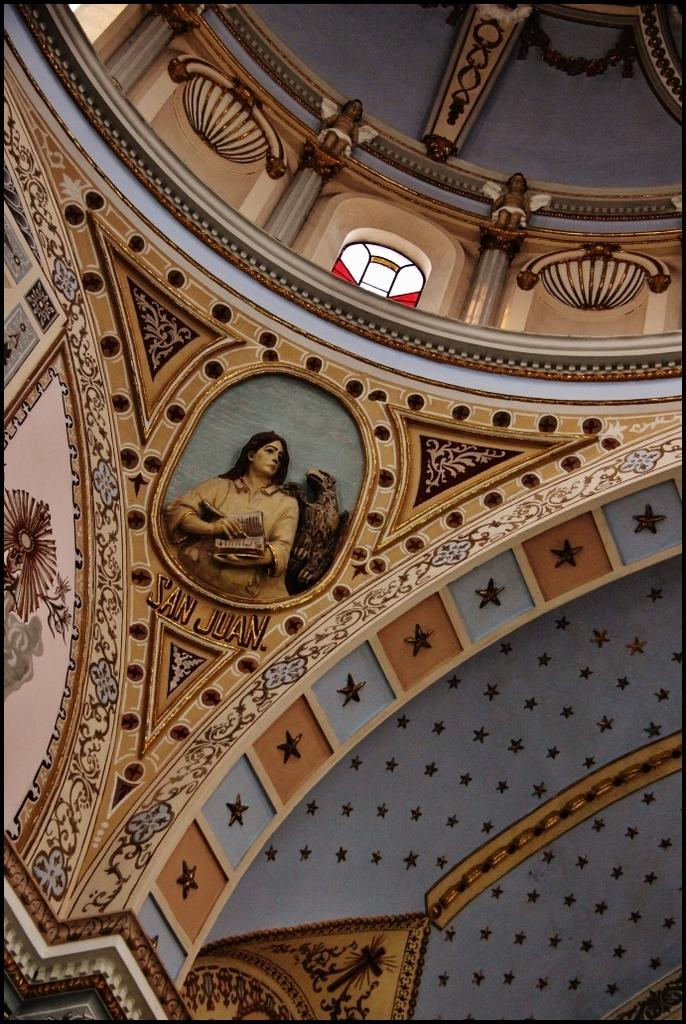What is present on the wall in the image? There is art on the wall in the image. Are there any other objects on the wall besides the art? Yes, there are objects on the wall. What can be seen at the top of the image? There is a window at the top of the image. What is the primary feature of the wall in the image? The primary feature of the wall is the art. What type of cushion can be seen on the wall in the image? There is no cushion present on the wall in the image. What is your dad doing in the image? There is no person, including a dad, present in the image. 